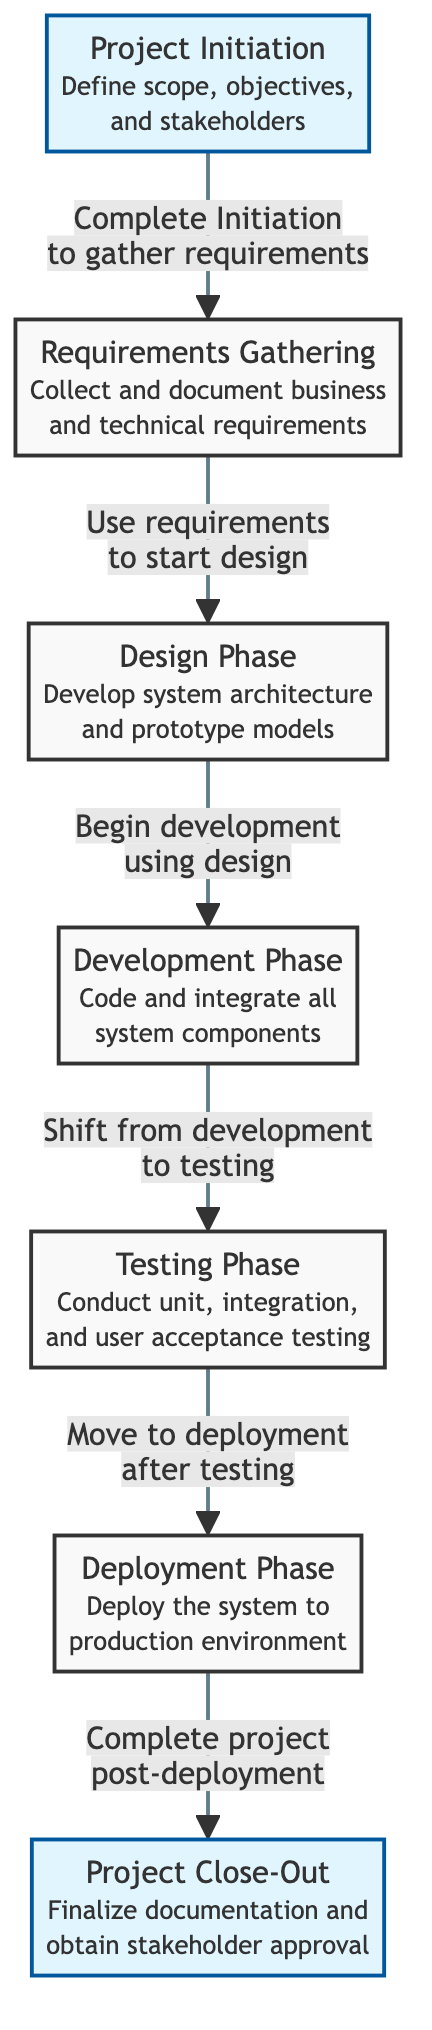What is the first milestone in the project timeline? The diagram indicates that the first milestone is "Project Initiation." This is the starting point of the project where the scope, objectives, and stakeholders are defined.
Answer: Project Initiation How many nodes are present in the diagram? The diagram has a total of seven nodes that represent the different phases of the project, including the milestones at the beginning and end.
Answer: Seven What phase comes after the Design Phase? The diagram shows a directed flow from the Design Phase to the Development Phase, indicating that Development follows Design.
Answer: Development Phase Which phase includes conducting user acceptance testing? The Testing Phase is specified in the diagram as the phase where unit, integration, and user acceptance testing are conducted, making it the correct answer.
Answer: Testing Phase What is the final phase of the project timeline? According to the diagram, the last phase is the "Project Close-Out," which involves finalizing documentation and obtaining stakeholder approval.
Answer: Project Close-Out How many relationships (arrows) are shown in the diagram? The diagram has six arrows (relationships) connecting the different phases, showing the sequential flow from one phase to another.
Answer: Six What is the action required to move from the Development Phase to the Testing Phase? The diagram specifies "Shift from development to testing," indicating the transition action required to go from Development to Testing.
Answer: Shift from development to testing Which two phases are milestones in the timeline? The diagram highlights "Project Initiation" and "Project Close-Out" as the milestones, which mark significant points in the project lifecycle.
Answer: Project Initiation, Project Close-Out 